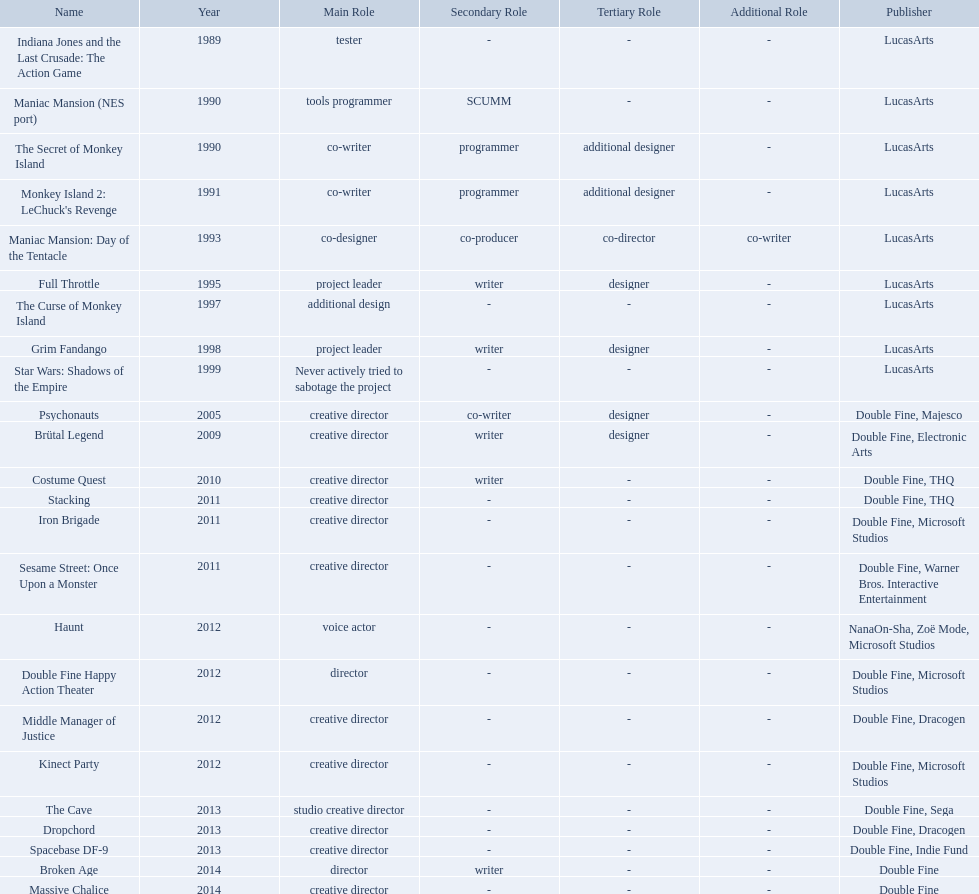Write the full table. {'header': ['Name', 'Year', 'Main Role', 'Secondary Role', 'Tertiary Role', 'Additional Role', 'Publisher'], 'rows': [['Indiana Jones and the Last Crusade: The Action Game', '1989', 'tester', '-', '-', '-', 'LucasArts'], ['Maniac Mansion (NES port)', '1990', 'tools programmer', 'SCUMM', '-', '-', 'LucasArts'], ['The Secret of Monkey Island', '1990', 'co-writer', 'programmer', 'additional designer', '-', 'LucasArts'], ["Monkey Island 2: LeChuck's Revenge", '1991', 'co-writer', 'programmer', 'additional designer', '-', 'LucasArts'], ['Maniac Mansion: Day of the Tentacle', '1993', 'co-designer', 'co-producer', 'co-director', 'co-writer', 'LucasArts'], ['Full Throttle', '1995', 'project leader', 'writer', 'designer', '-', 'LucasArts'], ['The Curse of Monkey Island', '1997', 'additional design', '-', '-', '-', 'LucasArts'], ['Grim Fandango', '1998', 'project leader', 'writer', 'designer', '-', 'LucasArts'], ['Star Wars: Shadows of the Empire', '1999', 'Never actively tried to sabotage the project', '-', '-', '-', 'LucasArts'], ['Psychonauts', '2005', 'creative director', 'co-writer', 'designer', '-', 'Double Fine, Majesco'], ['Brütal Legend', '2009', 'creative director', 'writer', 'designer', '-', 'Double Fine, Electronic Arts'], ['Costume Quest', '2010', 'creative director', 'writer', '-', '-', 'Double Fine, THQ'], ['Stacking', '2011', 'creative director', '-', '-', '-', 'Double Fine, THQ'], ['Iron Brigade', '2011', 'creative director', '-', '-', '-', 'Double Fine, Microsoft Studios'], ['Sesame Street: Once Upon a Monster', '2011', 'creative director', '-', '-', '-', 'Double Fine, Warner Bros. Interactive Entertainment'], ['Haunt', '2012', 'voice actor', '-', '-', '-', 'NanaOn-Sha, Zoë Mode, Microsoft Studios'], ['Double Fine Happy Action Theater', '2012', 'director', '-', '-', '-', 'Double Fine, Microsoft Studios'], ['Middle Manager of Justice', '2012', 'creative director', '-', '-', '-', 'Double Fine, Dracogen'], ['Kinect Party', '2012', 'creative director', '-', '-', '-', 'Double Fine, Microsoft Studios'], ['The Cave', '2013', 'studio creative director', '-', '-', '-', 'Double Fine, Sega'], ['Dropchord', '2013', 'creative director', '-', '-', '-', 'Double Fine, Dracogen'], ['Spacebase DF-9', '2013', 'creative director', '-', '-', '-', 'Double Fine, Indie Fund'], ['Broken Age', '2014', 'director', 'writer', '-', '-', 'Double Fine'], ['Massive Chalice', '2014', 'creative director', '-', '-', '-', 'Double Fine']]} Which game is credited with a creative director? Creative director, co-writer, designer, creative director, writer, designer, creative director, writer, creative director, creative director, creative director, creative director, creative director, creative director, creative director, creative director. Of these games, which also has warner bros. interactive listed as creative director? Sesame Street: Once Upon a Monster. What game name has tim schafer been involved with? Indiana Jones and the Last Crusade: The Action Game, Maniac Mansion (NES port), The Secret of Monkey Island, Monkey Island 2: LeChuck's Revenge, Maniac Mansion: Day of the Tentacle, Full Throttle, The Curse of Monkey Island, Grim Fandango, Star Wars: Shadows of the Empire, Psychonauts, Brütal Legend, Costume Quest, Stacking, Iron Brigade, Sesame Street: Once Upon a Monster, Haunt, Double Fine Happy Action Theater, Middle Manager of Justice, Kinect Party, The Cave, Dropchord, Spacebase DF-9, Broken Age, Massive Chalice. Which game has credit with just creative director? Creative director, creative director, creative director, creative director, creative director, creative director, creative director, creative director. Which games have the above and warner bros. interactive entertainment as publisher? Sesame Street: Once Upon a Monster. Which productions did tim schafer work on that were published in part by double fine? Psychonauts, Brütal Legend, Costume Quest, Stacking, Iron Brigade, Sesame Street: Once Upon a Monster, Double Fine Happy Action Theater, Middle Manager of Justice, Kinect Party, The Cave, Dropchord, Spacebase DF-9, Broken Age, Massive Chalice. Which of these was he a creative director? Psychonauts, Brütal Legend, Costume Quest, Stacking, Iron Brigade, Sesame Street: Once Upon a Monster, Middle Manager of Justice, Kinect Party, The Cave, Dropchord, Spacebase DF-9, Massive Chalice. Which of those were in 2011? Stacking, Iron Brigade, Sesame Street: Once Upon a Monster. What was the only one of these to be co published by warner brothers? Sesame Street: Once Upon a Monster. 